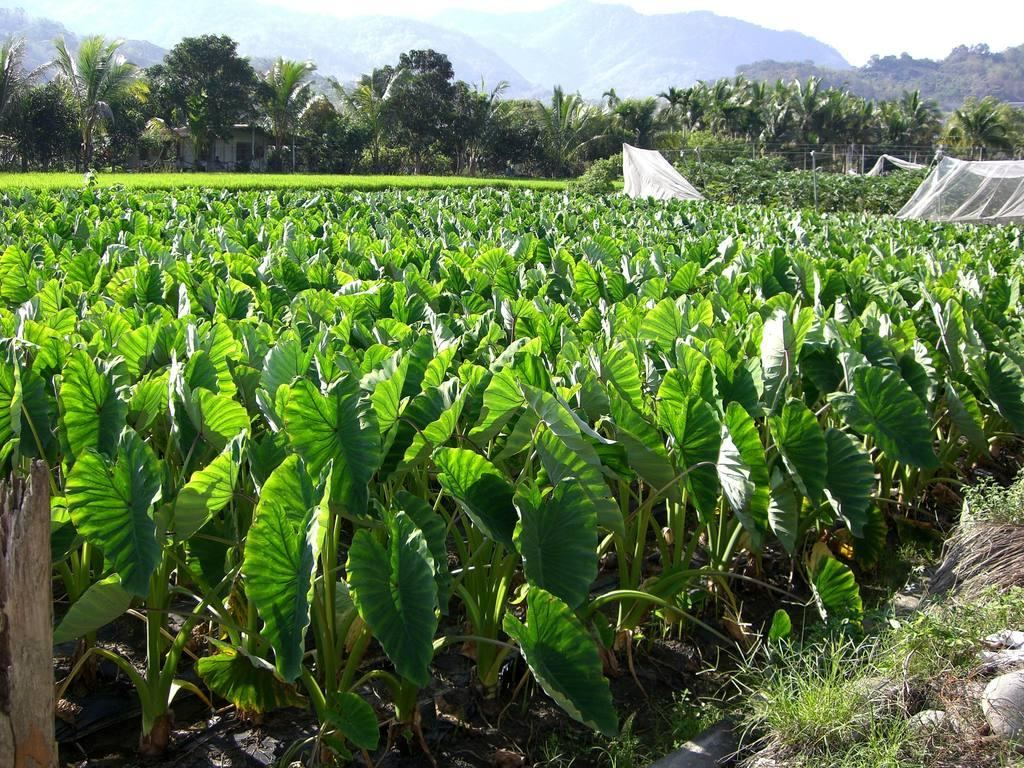What is the main subject of the image? The main subject of the image is a field with many crops. What can be seen surrounding the crops? There are plenty of trees around the crops. What is visible in the distance behind the crops and trees? There are mountains visible in the background of the image. What type of statement can be seen written on the heart in the image? There is no heart present in the image, so it is not possible to answer that question. 